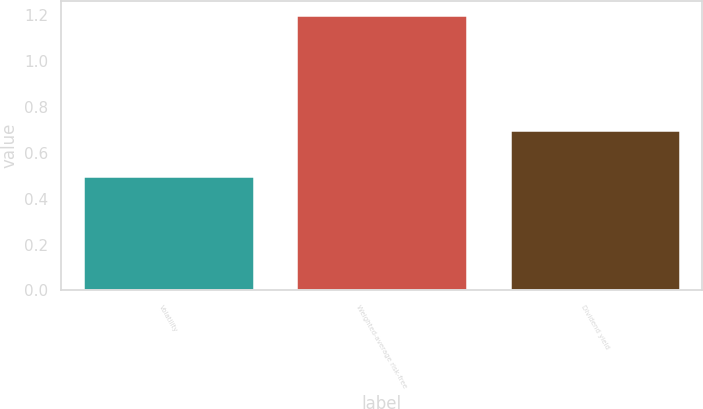Convert chart to OTSL. <chart><loc_0><loc_0><loc_500><loc_500><bar_chart><fcel>Volatility<fcel>Weighted-average risk-free<fcel>Dividend yield<nl><fcel>0.5<fcel>1.2<fcel>0.7<nl></chart> 